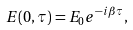Convert formula to latex. <formula><loc_0><loc_0><loc_500><loc_500>E ( 0 , \tau ) = E _ { 0 } e ^ { - i \beta \tau } ,</formula> 